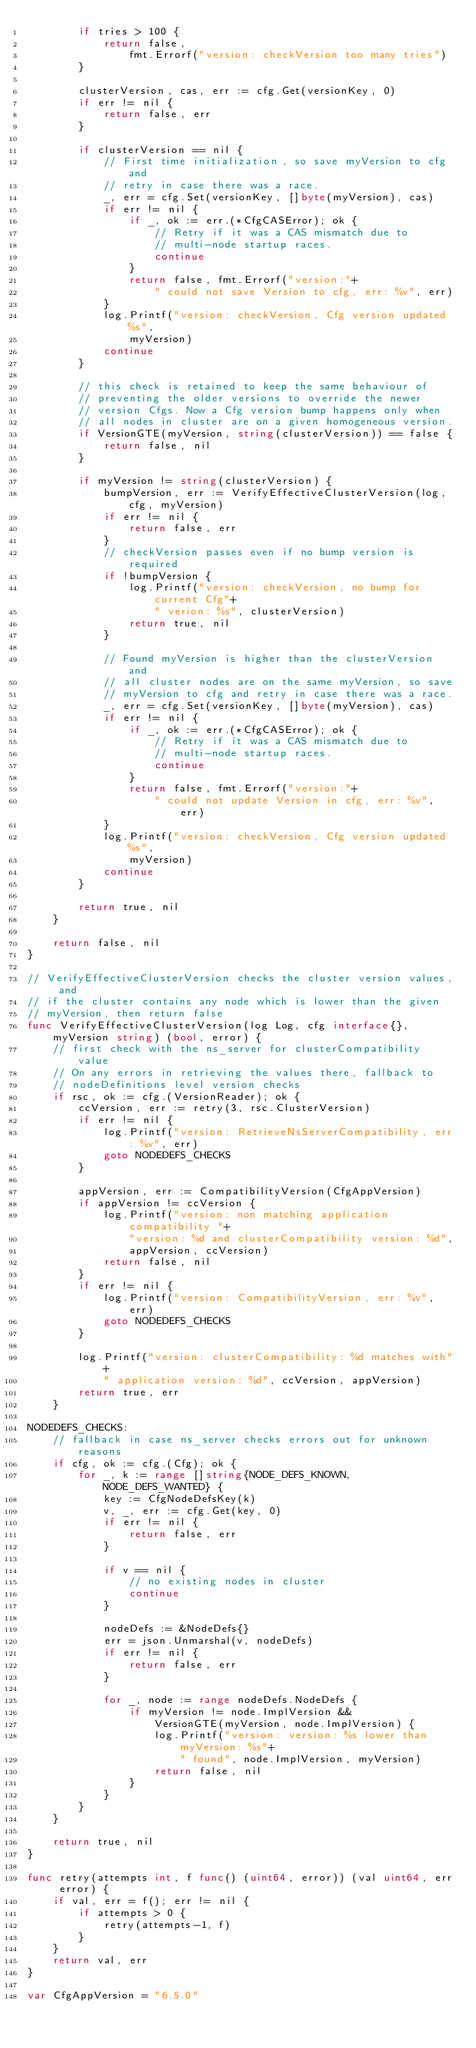<code> <loc_0><loc_0><loc_500><loc_500><_Go_>		if tries > 100 {
			return false,
				fmt.Errorf("version: checkVersion too many tries")
		}

		clusterVersion, cas, err := cfg.Get(versionKey, 0)
		if err != nil {
			return false, err
		}

		if clusterVersion == nil {
			// First time initialization, so save myVersion to cfg and
			// retry in case there was a race.
			_, err = cfg.Set(versionKey, []byte(myVersion), cas)
			if err != nil {
				if _, ok := err.(*CfgCASError); ok {
					// Retry if it was a CAS mismatch due to
					// multi-node startup races.
					continue
				}
				return false, fmt.Errorf("version:"+
					" could not save Version to cfg, err: %v", err)
			}
			log.Printf("version: checkVersion, Cfg version updated %s",
				myVersion)
			continue
		}

		// this check is retained to keep the same behaviour of
		// preventing the older versions to override the newer
		// version Cfgs. Now a Cfg version bump happens only when
		// all nodes in cluster are on a given homogeneous version.
		if VersionGTE(myVersion, string(clusterVersion)) == false {
			return false, nil
		}

		if myVersion != string(clusterVersion) {
			bumpVersion, err := VerifyEffectiveClusterVersion(log, cfg, myVersion)
			if err != nil {
				return false, err
			}
			// checkVersion passes even if no bump version is required
			if !bumpVersion {
				log.Printf("version: checkVersion, no bump for current Cfg"+
					" verion: %s", clusterVersion)
				return true, nil
			}

			// Found myVersion is higher than the clusterVersion and
			// all cluster nodes are on the same myVersion, so save
			// myVersion to cfg and retry in case there was a race.
			_, err = cfg.Set(versionKey, []byte(myVersion), cas)
			if err != nil {
				if _, ok := err.(*CfgCASError); ok {
					// Retry if it was a CAS mismatch due to
					// multi-node startup races.
					continue
				}
				return false, fmt.Errorf("version:"+
					" could not update Version in cfg, err: %v", err)
			}
			log.Printf("version: checkVersion, Cfg version updated %s",
				myVersion)
			continue
		}

		return true, nil
	}

	return false, nil
}

// VerifyEffectiveClusterVersion checks the cluster version values, and
// if the cluster contains any node which is lower than the given
// myVersion, then return false
func VerifyEffectiveClusterVersion(log Log, cfg interface{}, myVersion string) (bool, error) {
	// first check with the ns_server for clusterCompatibility value
	// On any errors in retrieving the values there, fallback to
	// nodeDefinitions level version checks
	if rsc, ok := cfg.(VersionReader); ok {
		ccVersion, err := retry(3, rsc.ClusterVersion)
		if err != nil {
			log.Printf("version: RetrieveNsServerCompatibility, err: %v", err)
			goto NODEDEFS_CHECKS
		}

		appVersion, err := CompatibilityVersion(CfgAppVersion)
		if appVersion != ccVersion {
			log.Printf("version: non matching application compatibility "+
				"version: %d and clusterCompatibility version: %d",
				appVersion, ccVersion)
			return false, nil
		}
		if err != nil {
			log.Printf("version: CompatibilityVersion, err: %v", err)
			goto NODEDEFS_CHECKS
		}

		log.Printf("version: clusterCompatibility: %d matches with"+
			" application version: %d", ccVersion, appVersion)
		return true, err
	}

NODEDEFS_CHECKS:
	// fallback in case ns_server checks errors out for unknown reasons
	if cfg, ok := cfg.(Cfg); ok {
		for _, k := range []string{NODE_DEFS_KNOWN, NODE_DEFS_WANTED} {
			key := CfgNodeDefsKey(k)
			v, _, err := cfg.Get(key, 0)
			if err != nil {
				return false, err
			}

			if v == nil {
				// no existing nodes in cluster
				continue
			}

			nodeDefs := &NodeDefs{}
			err = json.Unmarshal(v, nodeDefs)
			if err != nil {
				return false, err
			}

			for _, node := range nodeDefs.NodeDefs {
				if myVersion != node.ImplVersion &&
					VersionGTE(myVersion, node.ImplVersion) {
					log.Printf("version: version: %s lower than myVersion: %s"+
						" found", node.ImplVersion, myVersion)
					return false, nil
				}
			}
		}
	}

	return true, nil
}

func retry(attempts int, f func() (uint64, error)) (val uint64, err error) {
	if val, err = f(); err != nil {
		if attempts > 0 {
			retry(attempts-1, f)
		}
	}
	return val, err
}

var CfgAppVersion = "6.5.0"
</code> 